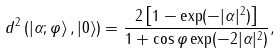<formula> <loc_0><loc_0><loc_500><loc_500>d ^ { 2 } \left ( | \alpha ; \varphi \rangle \, , | 0 \rangle \right ) = \frac { 2 \left [ 1 - \exp ( - | \alpha | ^ { 2 } ) \right ] } { 1 + \cos \varphi \exp ( - 2 | \alpha | ^ { 2 } ) } ,</formula> 